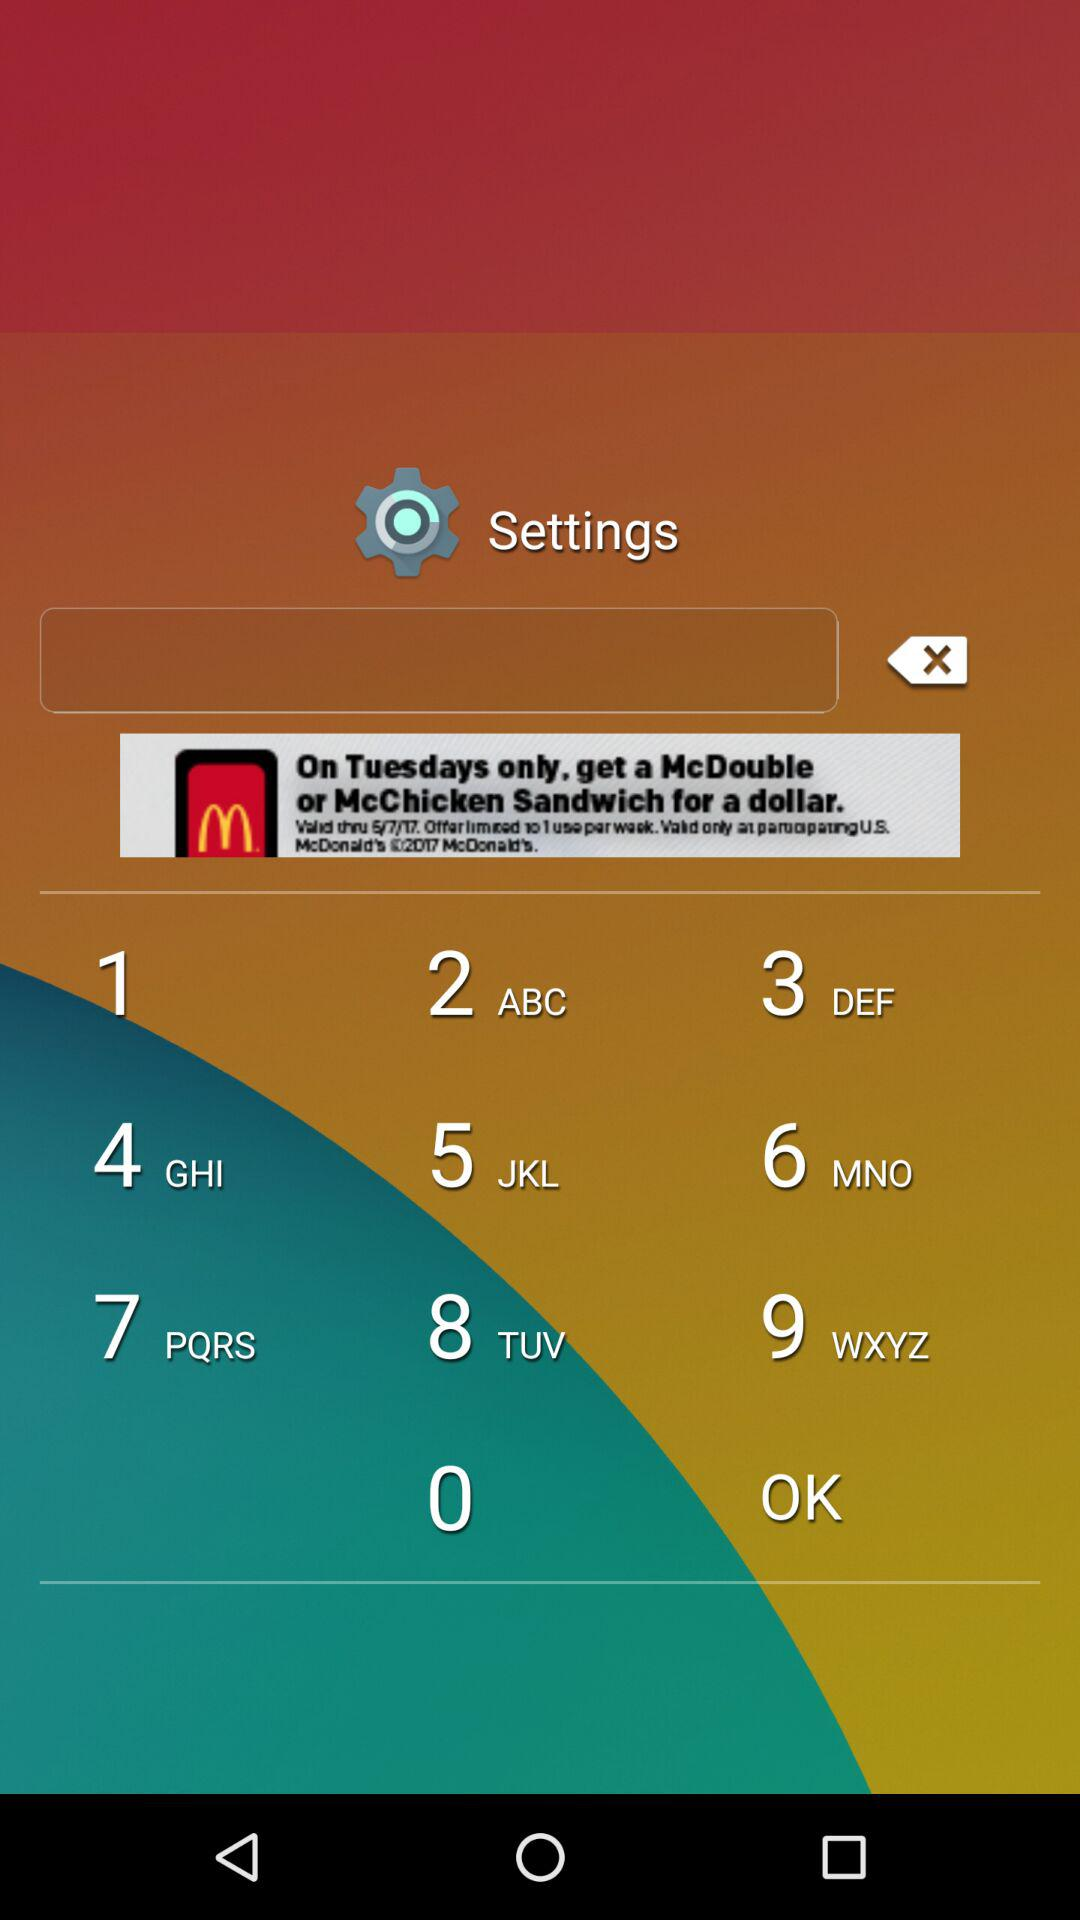How many steps are there in the process?
Answer the question using a single word or phrase. 3 